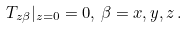Convert formula to latex. <formula><loc_0><loc_0><loc_500><loc_500>T _ { z \beta } | _ { z = 0 } = 0 , \, \beta = x , y , z \, .</formula> 